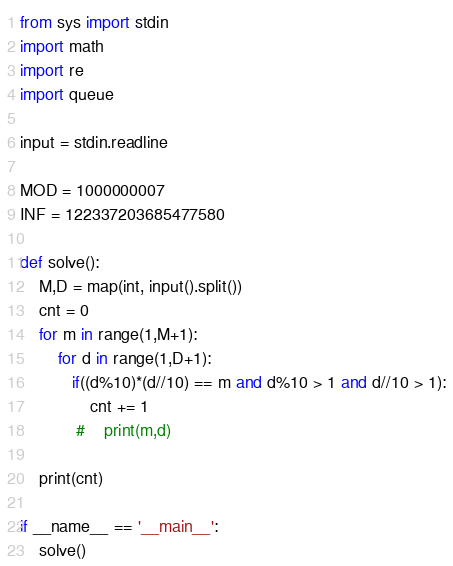Convert code to text. <code><loc_0><loc_0><loc_500><loc_500><_Python_>from sys import stdin
import math
import re
import queue

input = stdin.readline

MOD = 1000000007
INF = 122337203685477580

def solve():
    M,D = map(int, input().split())
    cnt = 0
    for m in range(1,M+1):
        for d in range(1,D+1):
           if((d%10)*(d//10) == m and d%10 > 1 and d//10 > 1):
               cnt += 1
            #    print(m,d)

    print(cnt) 

if __name__ == '__main__':
    solve()
</code> 